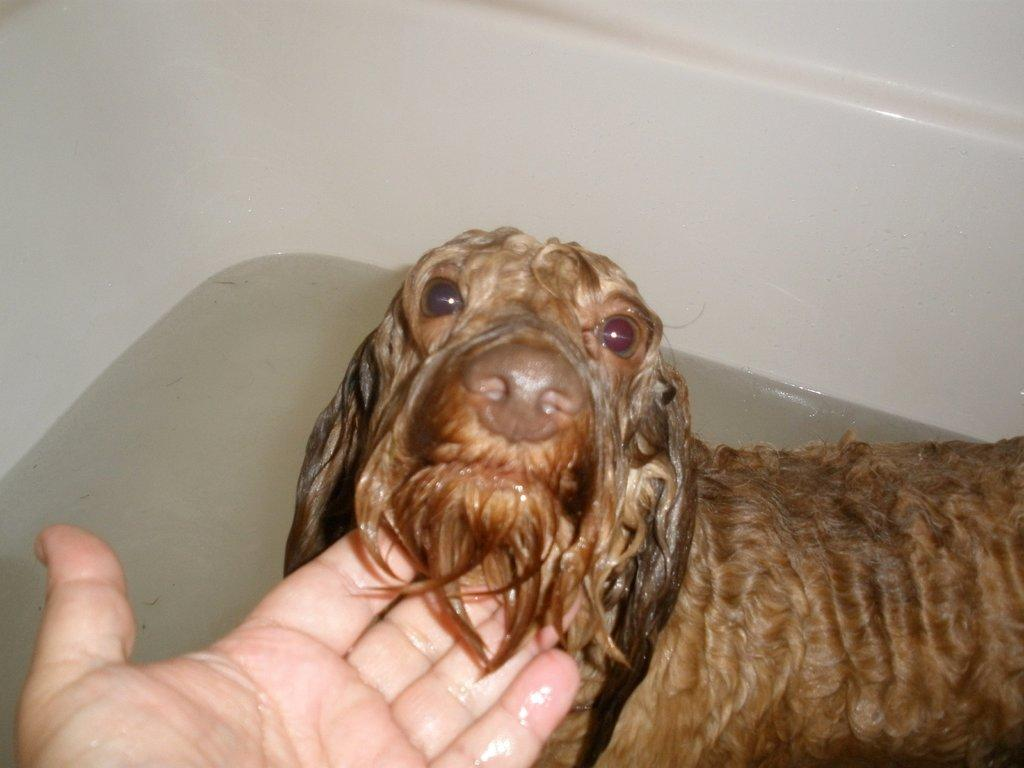What is the main subject of the image? There is a puppy in the image. Where is the puppy located? The puppy is in a bathtub. What is the puppy doing in the bathtub? The puppy is having a bath. Who is the puppy interacting with in the image? The puppy is licking someone's hand. What type of maid is visible in the image? There is no maid present in the image; it features a puppy in a bathtub. What kind of mist can be seen surrounding the puppy in the image? There is no mist present in the image; it is a clear scene of a puppy in a bathtub. 